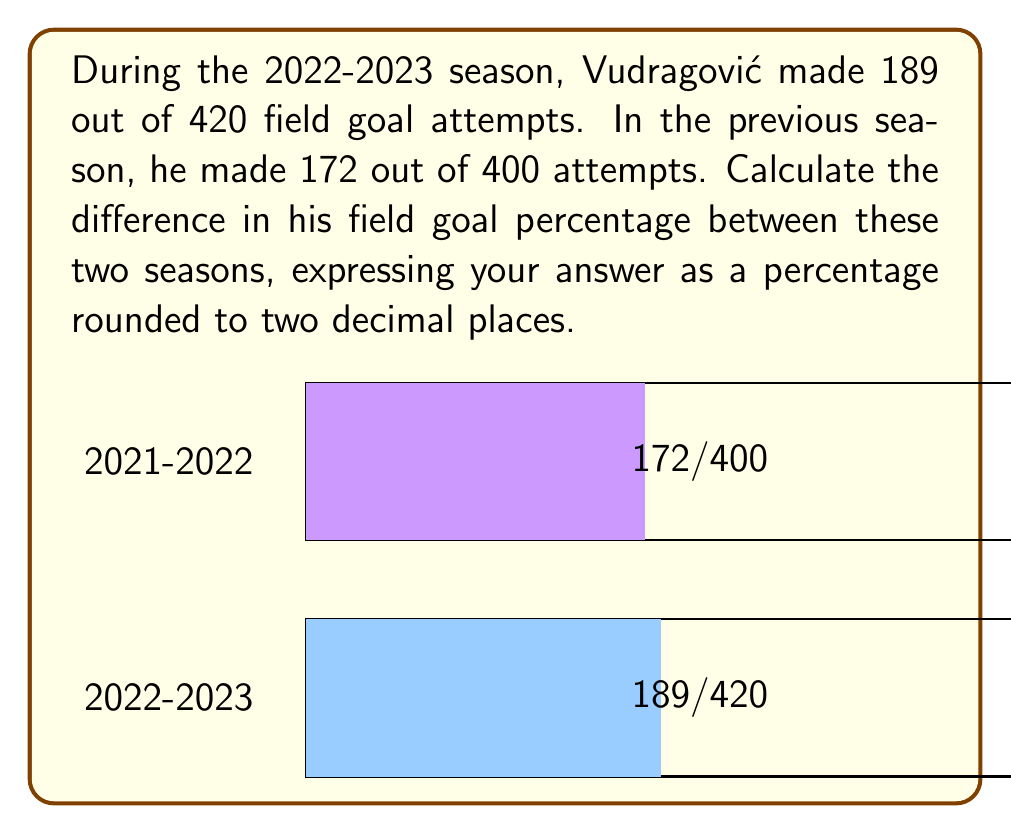Solve this math problem. Let's approach this step-by-step:

1) First, calculate the field goal percentage for the 2022-2023 season:
   $$\frac{189}{420} = 0.45 = 45\%$$

2) Now, calculate the field goal percentage for the 2021-2022 season:
   $$\frac{172}{400} = 0.43 = 43\%$$

3) To find the difference, subtract the 2021-2022 percentage from the 2022-2023 percentage:
   $$45\% - 43\% = 2\%$$

4) The question asks for the answer rounded to two decimal places. 2% is already in this form, so no further rounding is necessary.
Answer: 2.00% 